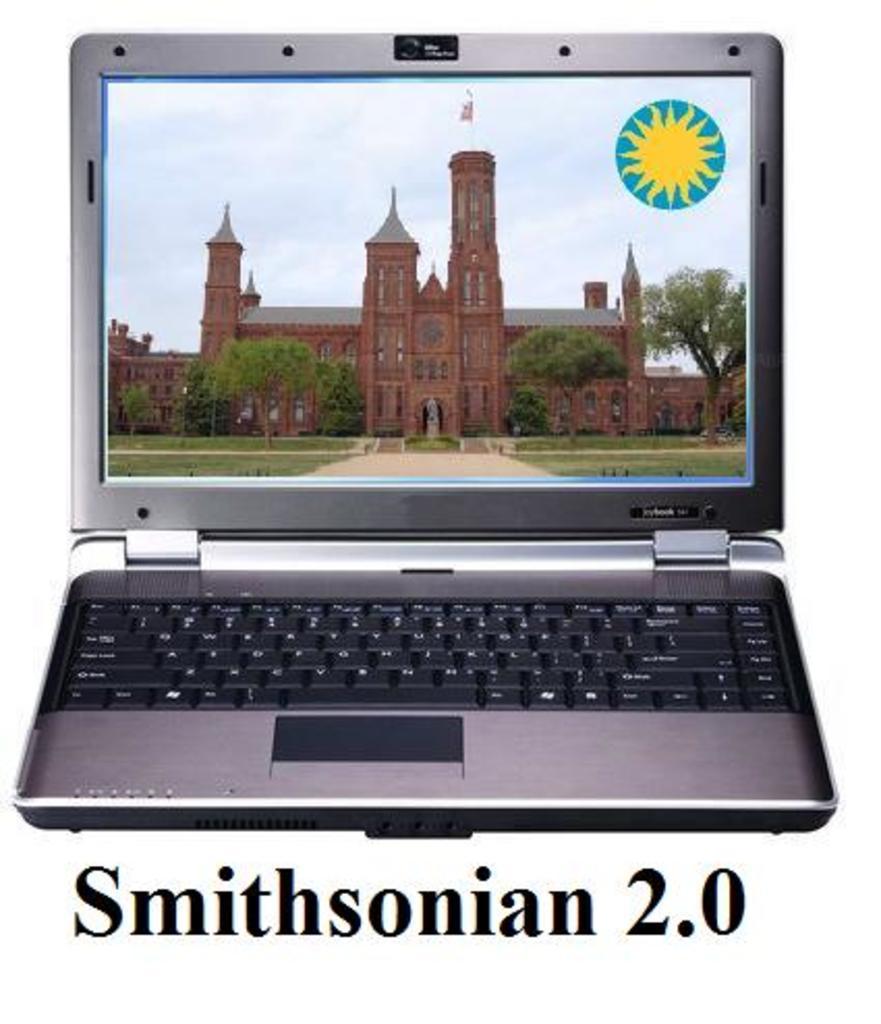What version of the smithsonian is being displayed?
Your answer should be very brief. 2.0. What is written on the key on the left with the arrow pointing up?
Your response must be concise. Shift. 